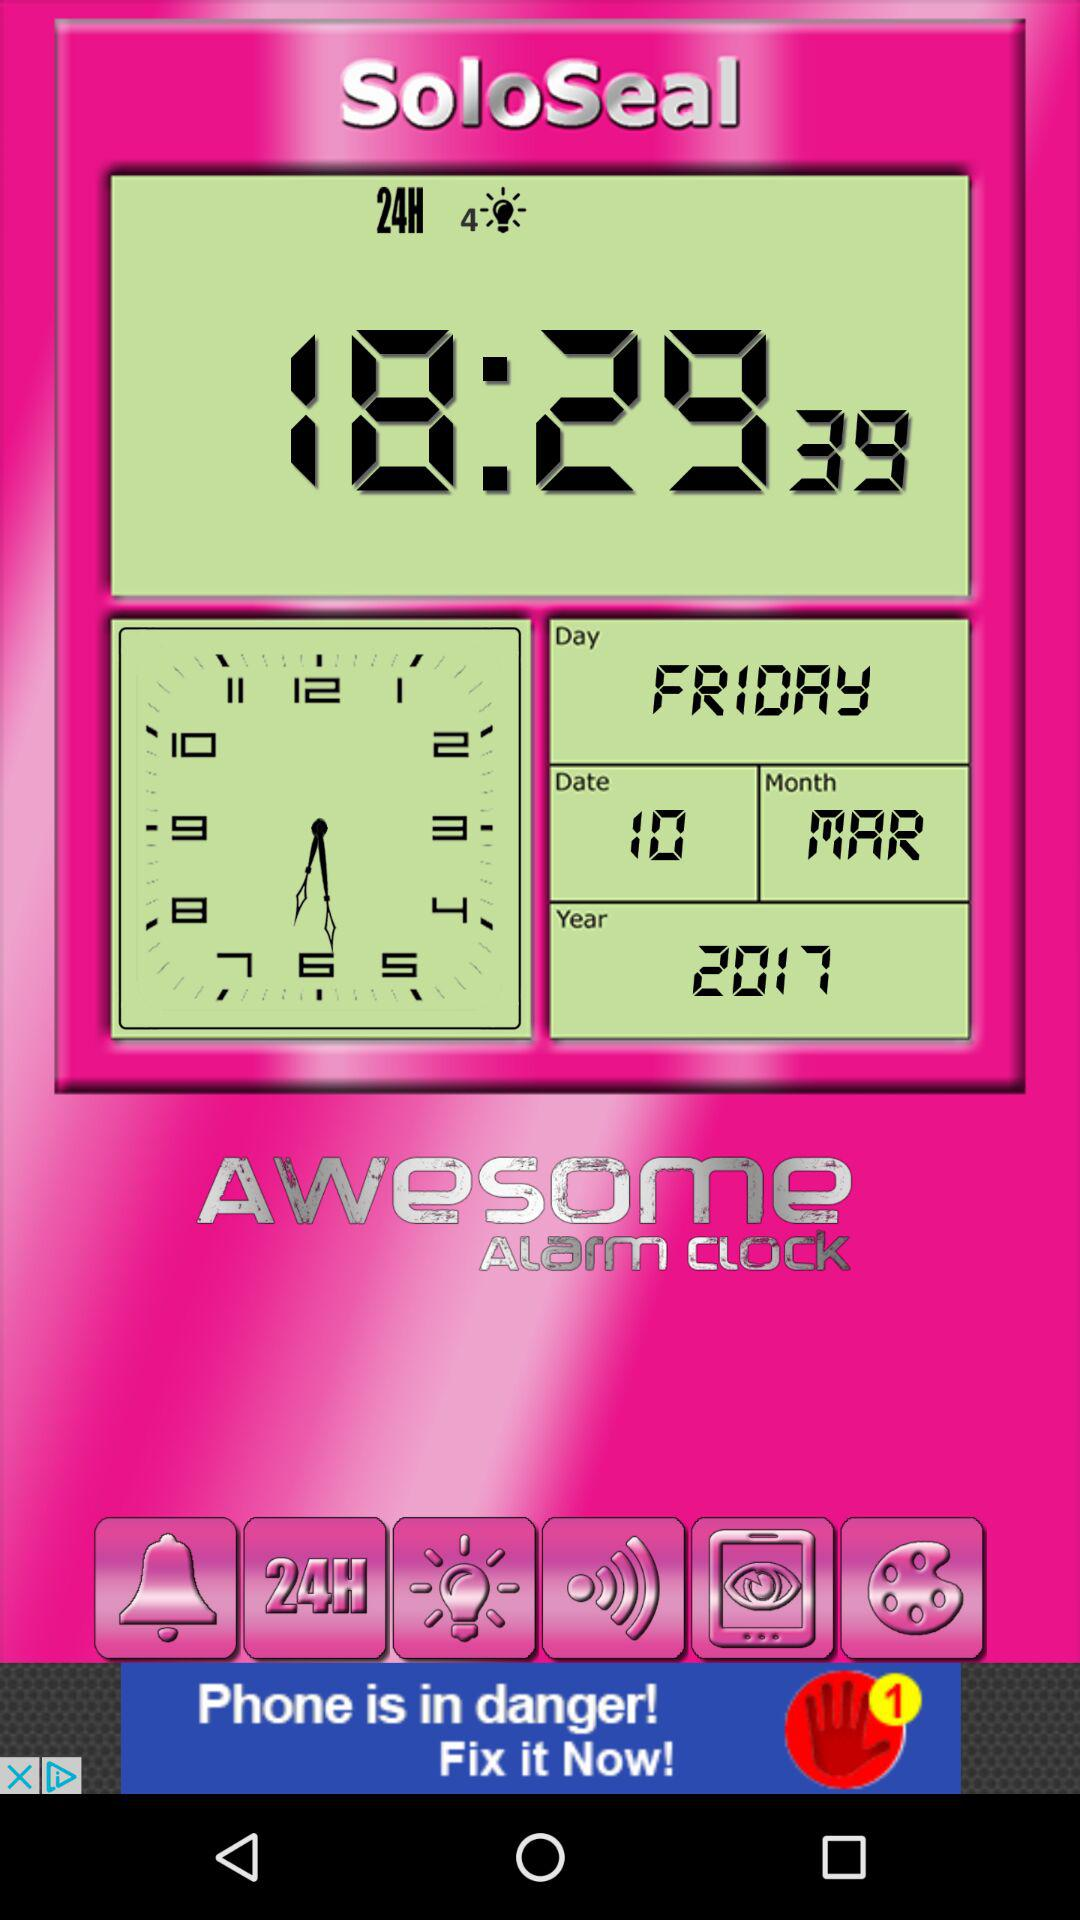What is the day on the selected date? The day on the selected date is Friday. 